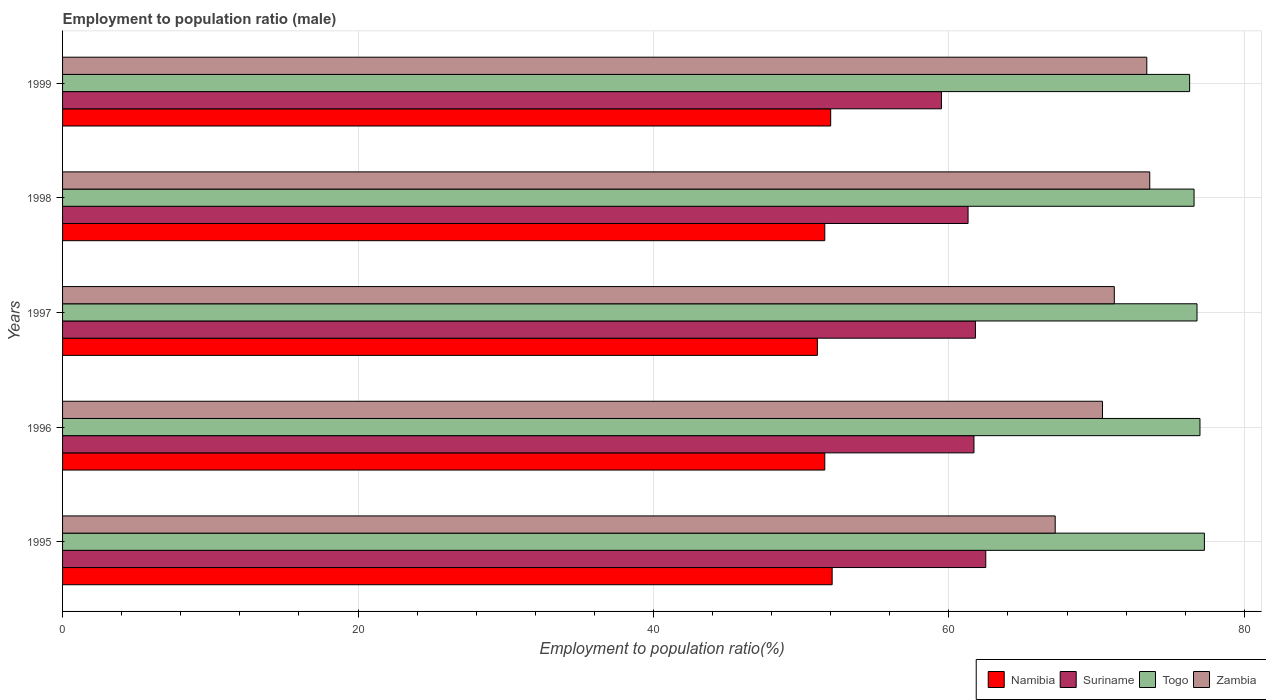How many different coloured bars are there?
Make the answer very short. 4. How many groups of bars are there?
Offer a very short reply. 5. How many bars are there on the 2nd tick from the bottom?
Make the answer very short. 4. What is the label of the 3rd group of bars from the top?
Your answer should be very brief. 1997. In how many cases, is the number of bars for a given year not equal to the number of legend labels?
Your response must be concise. 0. What is the employment to population ratio in Namibia in 1996?
Keep it short and to the point. 51.6. Across all years, what is the maximum employment to population ratio in Zambia?
Provide a succinct answer. 73.6. Across all years, what is the minimum employment to population ratio in Namibia?
Keep it short and to the point. 51.1. In which year was the employment to population ratio in Togo minimum?
Give a very brief answer. 1999. What is the total employment to population ratio in Zambia in the graph?
Your answer should be compact. 355.8. What is the difference between the employment to population ratio in Zambia in 1995 and that in 1999?
Offer a very short reply. -6.2. What is the difference between the employment to population ratio in Suriname in 1995 and the employment to population ratio in Namibia in 1999?
Your answer should be compact. 10.5. What is the average employment to population ratio in Zambia per year?
Offer a terse response. 71.16. In the year 1998, what is the difference between the employment to population ratio in Namibia and employment to population ratio in Suriname?
Your answer should be very brief. -9.7. In how many years, is the employment to population ratio in Togo greater than 32 %?
Your answer should be very brief. 5. What is the ratio of the employment to population ratio in Namibia in 1995 to that in 1998?
Make the answer very short. 1.01. Is the employment to population ratio in Suriname in 1996 less than that in 1998?
Give a very brief answer. No. What is the difference between the highest and the second highest employment to population ratio in Suriname?
Give a very brief answer. 0.7. Is it the case that in every year, the sum of the employment to population ratio in Suriname and employment to population ratio in Togo is greater than the sum of employment to population ratio in Zambia and employment to population ratio in Namibia?
Your answer should be compact. Yes. What does the 3rd bar from the top in 1998 represents?
Provide a short and direct response. Suriname. What does the 2nd bar from the bottom in 1995 represents?
Ensure brevity in your answer.  Suriname. Are all the bars in the graph horizontal?
Keep it short and to the point. Yes. How many years are there in the graph?
Give a very brief answer. 5. Are the values on the major ticks of X-axis written in scientific E-notation?
Ensure brevity in your answer.  No. Does the graph contain any zero values?
Your answer should be compact. No. Where does the legend appear in the graph?
Offer a terse response. Bottom right. How are the legend labels stacked?
Provide a short and direct response. Horizontal. What is the title of the graph?
Your response must be concise. Employment to population ratio (male). What is the label or title of the X-axis?
Give a very brief answer. Employment to population ratio(%). What is the label or title of the Y-axis?
Your answer should be very brief. Years. What is the Employment to population ratio(%) in Namibia in 1995?
Ensure brevity in your answer.  52.1. What is the Employment to population ratio(%) of Suriname in 1995?
Ensure brevity in your answer.  62.5. What is the Employment to population ratio(%) of Togo in 1995?
Ensure brevity in your answer.  77.3. What is the Employment to population ratio(%) of Zambia in 1995?
Provide a succinct answer. 67.2. What is the Employment to population ratio(%) of Namibia in 1996?
Provide a succinct answer. 51.6. What is the Employment to population ratio(%) of Suriname in 1996?
Make the answer very short. 61.7. What is the Employment to population ratio(%) of Togo in 1996?
Keep it short and to the point. 77. What is the Employment to population ratio(%) of Zambia in 1996?
Offer a very short reply. 70.4. What is the Employment to population ratio(%) of Namibia in 1997?
Provide a short and direct response. 51.1. What is the Employment to population ratio(%) of Suriname in 1997?
Make the answer very short. 61.8. What is the Employment to population ratio(%) of Togo in 1997?
Your answer should be very brief. 76.8. What is the Employment to population ratio(%) of Zambia in 1997?
Make the answer very short. 71.2. What is the Employment to population ratio(%) in Namibia in 1998?
Your answer should be compact. 51.6. What is the Employment to population ratio(%) of Suriname in 1998?
Provide a succinct answer. 61.3. What is the Employment to population ratio(%) in Togo in 1998?
Provide a succinct answer. 76.6. What is the Employment to population ratio(%) in Zambia in 1998?
Your response must be concise. 73.6. What is the Employment to population ratio(%) of Namibia in 1999?
Offer a terse response. 52. What is the Employment to population ratio(%) in Suriname in 1999?
Provide a succinct answer. 59.5. What is the Employment to population ratio(%) in Togo in 1999?
Provide a succinct answer. 76.3. What is the Employment to population ratio(%) in Zambia in 1999?
Provide a short and direct response. 73.4. Across all years, what is the maximum Employment to population ratio(%) of Namibia?
Make the answer very short. 52.1. Across all years, what is the maximum Employment to population ratio(%) in Suriname?
Your response must be concise. 62.5. Across all years, what is the maximum Employment to population ratio(%) in Togo?
Offer a terse response. 77.3. Across all years, what is the maximum Employment to population ratio(%) in Zambia?
Give a very brief answer. 73.6. Across all years, what is the minimum Employment to population ratio(%) of Namibia?
Your response must be concise. 51.1. Across all years, what is the minimum Employment to population ratio(%) in Suriname?
Provide a succinct answer. 59.5. Across all years, what is the minimum Employment to population ratio(%) in Togo?
Your answer should be very brief. 76.3. Across all years, what is the minimum Employment to population ratio(%) in Zambia?
Provide a short and direct response. 67.2. What is the total Employment to population ratio(%) in Namibia in the graph?
Offer a very short reply. 258.4. What is the total Employment to population ratio(%) in Suriname in the graph?
Your response must be concise. 306.8. What is the total Employment to population ratio(%) in Togo in the graph?
Your answer should be very brief. 384. What is the total Employment to population ratio(%) in Zambia in the graph?
Make the answer very short. 355.8. What is the difference between the Employment to population ratio(%) of Namibia in 1995 and that in 1996?
Your response must be concise. 0.5. What is the difference between the Employment to population ratio(%) of Zambia in 1995 and that in 1996?
Keep it short and to the point. -3.2. What is the difference between the Employment to population ratio(%) in Togo in 1995 and that in 1997?
Your response must be concise. 0.5. What is the difference between the Employment to population ratio(%) of Namibia in 1995 and that in 1998?
Your response must be concise. 0.5. What is the difference between the Employment to population ratio(%) in Togo in 1995 and that in 1998?
Ensure brevity in your answer.  0.7. What is the difference between the Employment to population ratio(%) in Suriname in 1995 and that in 1999?
Provide a succinct answer. 3. What is the difference between the Employment to population ratio(%) in Togo in 1995 and that in 1999?
Keep it short and to the point. 1. What is the difference between the Employment to population ratio(%) in Namibia in 1996 and that in 1997?
Provide a succinct answer. 0.5. What is the difference between the Employment to population ratio(%) in Suriname in 1996 and that in 1997?
Your answer should be very brief. -0.1. What is the difference between the Employment to population ratio(%) of Togo in 1996 and that in 1997?
Keep it short and to the point. 0.2. What is the difference between the Employment to population ratio(%) in Zambia in 1996 and that in 1997?
Provide a short and direct response. -0.8. What is the difference between the Employment to population ratio(%) in Togo in 1996 and that in 1998?
Give a very brief answer. 0.4. What is the difference between the Employment to population ratio(%) in Zambia in 1996 and that in 1999?
Offer a very short reply. -3. What is the difference between the Employment to population ratio(%) in Zambia in 1997 and that in 1998?
Give a very brief answer. -2.4. What is the difference between the Employment to population ratio(%) of Namibia in 1997 and that in 1999?
Offer a very short reply. -0.9. What is the difference between the Employment to population ratio(%) in Suriname in 1997 and that in 1999?
Keep it short and to the point. 2.3. What is the difference between the Employment to population ratio(%) of Zambia in 1997 and that in 1999?
Provide a succinct answer. -2.2. What is the difference between the Employment to population ratio(%) in Togo in 1998 and that in 1999?
Provide a short and direct response. 0.3. What is the difference between the Employment to population ratio(%) of Zambia in 1998 and that in 1999?
Ensure brevity in your answer.  0.2. What is the difference between the Employment to population ratio(%) of Namibia in 1995 and the Employment to population ratio(%) of Togo in 1996?
Provide a short and direct response. -24.9. What is the difference between the Employment to population ratio(%) of Namibia in 1995 and the Employment to population ratio(%) of Zambia in 1996?
Give a very brief answer. -18.3. What is the difference between the Employment to population ratio(%) of Suriname in 1995 and the Employment to population ratio(%) of Togo in 1996?
Ensure brevity in your answer.  -14.5. What is the difference between the Employment to population ratio(%) in Namibia in 1995 and the Employment to population ratio(%) in Suriname in 1997?
Your response must be concise. -9.7. What is the difference between the Employment to population ratio(%) in Namibia in 1995 and the Employment to population ratio(%) in Togo in 1997?
Keep it short and to the point. -24.7. What is the difference between the Employment to population ratio(%) in Namibia in 1995 and the Employment to population ratio(%) in Zambia in 1997?
Your answer should be very brief. -19.1. What is the difference between the Employment to population ratio(%) of Suriname in 1995 and the Employment to population ratio(%) of Togo in 1997?
Give a very brief answer. -14.3. What is the difference between the Employment to population ratio(%) of Togo in 1995 and the Employment to population ratio(%) of Zambia in 1997?
Ensure brevity in your answer.  6.1. What is the difference between the Employment to population ratio(%) in Namibia in 1995 and the Employment to population ratio(%) in Togo in 1998?
Provide a short and direct response. -24.5. What is the difference between the Employment to population ratio(%) in Namibia in 1995 and the Employment to population ratio(%) in Zambia in 1998?
Give a very brief answer. -21.5. What is the difference between the Employment to population ratio(%) of Suriname in 1995 and the Employment to population ratio(%) of Togo in 1998?
Provide a short and direct response. -14.1. What is the difference between the Employment to population ratio(%) in Suriname in 1995 and the Employment to population ratio(%) in Zambia in 1998?
Keep it short and to the point. -11.1. What is the difference between the Employment to population ratio(%) of Togo in 1995 and the Employment to population ratio(%) of Zambia in 1998?
Offer a very short reply. 3.7. What is the difference between the Employment to population ratio(%) of Namibia in 1995 and the Employment to population ratio(%) of Suriname in 1999?
Offer a very short reply. -7.4. What is the difference between the Employment to population ratio(%) of Namibia in 1995 and the Employment to population ratio(%) of Togo in 1999?
Offer a terse response. -24.2. What is the difference between the Employment to population ratio(%) of Namibia in 1995 and the Employment to population ratio(%) of Zambia in 1999?
Ensure brevity in your answer.  -21.3. What is the difference between the Employment to population ratio(%) in Suriname in 1995 and the Employment to population ratio(%) in Zambia in 1999?
Provide a succinct answer. -10.9. What is the difference between the Employment to population ratio(%) of Togo in 1995 and the Employment to population ratio(%) of Zambia in 1999?
Ensure brevity in your answer.  3.9. What is the difference between the Employment to population ratio(%) of Namibia in 1996 and the Employment to population ratio(%) of Suriname in 1997?
Your answer should be compact. -10.2. What is the difference between the Employment to population ratio(%) of Namibia in 1996 and the Employment to population ratio(%) of Togo in 1997?
Offer a terse response. -25.2. What is the difference between the Employment to population ratio(%) in Namibia in 1996 and the Employment to population ratio(%) in Zambia in 1997?
Your response must be concise. -19.6. What is the difference between the Employment to population ratio(%) in Suriname in 1996 and the Employment to population ratio(%) in Togo in 1997?
Provide a succinct answer. -15.1. What is the difference between the Employment to population ratio(%) in Suriname in 1996 and the Employment to population ratio(%) in Zambia in 1997?
Make the answer very short. -9.5. What is the difference between the Employment to population ratio(%) in Namibia in 1996 and the Employment to population ratio(%) in Togo in 1998?
Provide a short and direct response. -25. What is the difference between the Employment to population ratio(%) of Namibia in 1996 and the Employment to population ratio(%) of Zambia in 1998?
Keep it short and to the point. -22. What is the difference between the Employment to population ratio(%) of Suriname in 1996 and the Employment to population ratio(%) of Togo in 1998?
Offer a terse response. -14.9. What is the difference between the Employment to population ratio(%) of Namibia in 1996 and the Employment to population ratio(%) of Togo in 1999?
Offer a terse response. -24.7. What is the difference between the Employment to population ratio(%) of Namibia in 1996 and the Employment to population ratio(%) of Zambia in 1999?
Offer a very short reply. -21.8. What is the difference between the Employment to population ratio(%) in Suriname in 1996 and the Employment to population ratio(%) in Togo in 1999?
Your response must be concise. -14.6. What is the difference between the Employment to population ratio(%) in Suriname in 1996 and the Employment to population ratio(%) in Zambia in 1999?
Provide a short and direct response. -11.7. What is the difference between the Employment to population ratio(%) in Togo in 1996 and the Employment to population ratio(%) in Zambia in 1999?
Ensure brevity in your answer.  3.6. What is the difference between the Employment to population ratio(%) in Namibia in 1997 and the Employment to population ratio(%) in Suriname in 1998?
Keep it short and to the point. -10.2. What is the difference between the Employment to population ratio(%) in Namibia in 1997 and the Employment to population ratio(%) in Togo in 1998?
Your response must be concise. -25.5. What is the difference between the Employment to population ratio(%) in Namibia in 1997 and the Employment to population ratio(%) in Zambia in 1998?
Offer a terse response. -22.5. What is the difference between the Employment to population ratio(%) in Suriname in 1997 and the Employment to population ratio(%) in Togo in 1998?
Offer a terse response. -14.8. What is the difference between the Employment to population ratio(%) of Suriname in 1997 and the Employment to population ratio(%) of Zambia in 1998?
Provide a short and direct response. -11.8. What is the difference between the Employment to population ratio(%) of Togo in 1997 and the Employment to population ratio(%) of Zambia in 1998?
Make the answer very short. 3.2. What is the difference between the Employment to population ratio(%) of Namibia in 1997 and the Employment to population ratio(%) of Togo in 1999?
Offer a terse response. -25.2. What is the difference between the Employment to population ratio(%) in Namibia in 1997 and the Employment to population ratio(%) in Zambia in 1999?
Provide a short and direct response. -22.3. What is the difference between the Employment to population ratio(%) in Suriname in 1997 and the Employment to population ratio(%) in Togo in 1999?
Your answer should be very brief. -14.5. What is the difference between the Employment to population ratio(%) in Togo in 1997 and the Employment to population ratio(%) in Zambia in 1999?
Provide a short and direct response. 3.4. What is the difference between the Employment to population ratio(%) of Namibia in 1998 and the Employment to population ratio(%) of Togo in 1999?
Offer a terse response. -24.7. What is the difference between the Employment to population ratio(%) in Namibia in 1998 and the Employment to population ratio(%) in Zambia in 1999?
Your answer should be compact. -21.8. What is the difference between the Employment to population ratio(%) of Suriname in 1998 and the Employment to population ratio(%) of Togo in 1999?
Give a very brief answer. -15. What is the difference between the Employment to population ratio(%) in Togo in 1998 and the Employment to population ratio(%) in Zambia in 1999?
Offer a very short reply. 3.2. What is the average Employment to population ratio(%) in Namibia per year?
Provide a succinct answer. 51.68. What is the average Employment to population ratio(%) in Suriname per year?
Your answer should be compact. 61.36. What is the average Employment to population ratio(%) in Togo per year?
Your answer should be compact. 76.8. What is the average Employment to population ratio(%) in Zambia per year?
Offer a terse response. 71.16. In the year 1995, what is the difference between the Employment to population ratio(%) of Namibia and Employment to population ratio(%) of Suriname?
Your answer should be compact. -10.4. In the year 1995, what is the difference between the Employment to population ratio(%) of Namibia and Employment to population ratio(%) of Togo?
Provide a succinct answer. -25.2. In the year 1995, what is the difference between the Employment to population ratio(%) in Namibia and Employment to population ratio(%) in Zambia?
Give a very brief answer. -15.1. In the year 1995, what is the difference between the Employment to population ratio(%) of Suriname and Employment to population ratio(%) of Togo?
Provide a succinct answer. -14.8. In the year 1995, what is the difference between the Employment to population ratio(%) in Suriname and Employment to population ratio(%) in Zambia?
Ensure brevity in your answer.  -4.7. In the year 1995, what is the difference between the Employment to population ratio(%) of Togo and Employment to population ratio(%) of Zambia?
Your response must be concise. 10.1. In the year 1996, what is the difference between the Employment to population ratio(%) in Namibia and Employment to population ratio(%) in Suriname?
Provide a short and direct response. -10.1. In the year 1996, what is the difference between the Employment to population ratio(%) of Namibia and Employment to population ratio(%) of Togo?
Provide a succinct answer. -25.4. In the year 1996, what is the difference between the Employment to population ratio(%) in Namibia and Employment to population ratio(%) in Zambia?
Offer a terse response. -18.8. In the year 1996, what is the difference between the Employment to population ratio(%) of Suriname and Employment to population ratio(%) of Togo?
Ensure brevity in your answer.  -15.3. In the year 1996, what is the difference between the Employment to population ratio(%) of Togo and Employment to population ratio(%) of Zambia?
Your response must be concise. 6.6. In the year 1997, what is the difference between the Employment to population ratio(%) in Namibia and Employment to population ratio(%) in Suriname?
Your response must be concise. -10.7. In the year 1997, what is the difference between the Employment to population ratio(%) of Namibia and Employment to population ratio(%) of Togo?
Provide a succinct answer. -25.7. In the year 1997, what is the difference between the Employment to population ratio(%) of Namibia and Employment to population ratio(%) of Zambia?
Provide a short and direct response. -20.1. In the year 1997, what is the difference between the Employment to population ratio(%) in Suriname and Employment to population ratio(%) in Togo?
Make the answer very short. -15. In the year 1997, what is the difference between the Employment to population ratio(%) in Suriname and Employment to population ratio(%) in Zambia?
Offer a terse response. -9.4. In the year 1997, what is the difference between the Employment to population ratio(%) in Togo and Employment to population ratio(%) in Zambia?
Ensure brevity in your answer.  5.6. In the year 1998, what is the difference between the Employment to population ratio(%) in Namibia and Employment to population ratio(%) in Suriname?
Give a very brief answer. -9.7. In the year 1998, what is the difference between the Employment to population ratio(%) in Namibia and Employment to population ratio(%) in Togo?
Your response must be concise. -25. In the year 1998, what is the difference between the Employment to population ratio(%) of Namibia and Employment to population ratio(%) of Zambia?
Keep it short and to the point. -22. In the year 1998, what is the difference between the Employment to population ratio(%) of Suriname and Employment to population ratio(%) of Togo?
Give a very brief answer. -15.3. In the year 1998, what is the difference between the Employment to population ratio(%) in Togo and Employment to population ratio(%) in Zambia?
Your answer should be very brief. 3. In the year 1999, what is the difference between the Employment to population ratio(%) of Namibia and Employment to population ratio(%) of Togo?
Offer a very short reply. -24.3. In the year 1999, what is the difference between the Employment to population ratio(%) in Namibia and Employment to population ratio(%) in Zambia?
Your answer should be compact. -21.4. In the year 1999, what is the difference between the Employment to population ratio(%) in Suriname and Employment to population ratio(%) in Togo?
Your answer should be very brief. -16.8. In the year 1999, what is the difference between the Employment to population ratio(%) of Togo and Employment to population ratio(%) of Zambia?
Ensure brevity in your answer.  2.9. What is the ratio of the Employment to population ratio(%) of Namibia in 1995 to that in 1996?
Your answer should be compact. 1.01. What is the ratio of the Employment to population ratio(%) of Suriname in 1995 to that in 1996?
Make the answer very short. 1.01. What is the ratio of the Employment to population ratio(%) in Togo in 1995 to that in 1996?
Your response must be concise. 1. What is the ratio of the Employment to population ratio(%) in Zambia in 1995 to that in 1996?
Your response must be concise. 0.95. What is the ratio of the Employment to population ratio(%) of Namibia in 1995 to that in 1997?
Make the answer very short. 1.02. What is the ratio of the Employment to population ratio(%) in Suriname in 1995 to that in 1997?
Keep it short and to the point. 1.01. What is the ratio of the Employment to population ratio(%) of Togo in 1995 to that in 1997?
Your answer should be very brief. 1.01. What is the ratio of the Employment to population ratio(%) in Zambia in 1995 to that in 1997?
Provide a short and direct response. 0.94. What is the ratio of the Employment to population ratio(%) of Namibia in 1995 to that in 1998?
Ensure brevity in your answer.  1.01. What is the ratio of the Employment to population ratio(%) of Suriname in 1995 to that in 1998?
Provide a short and direct response. 1.02. What is the ratio of the Employment to population ratio(%) in Togo in 1995 to that in 1998?
Provide a short and direct response. 1.01. What is the ratio of the Employment to population ratio(%) in Suriname in 1995 to that in 1999?
Provide a short and direct response. 1.05. What is the ratio of the Employment to population ratio(%) in Togo in 1995 to that in 1999?
Your response must be concise. 1.01. What is the ratio of the Employment to population ratio(%) of Zambia in 1995 to that in 1999?
Keep it short and to the point. 0.92. What is the ratio of the Employment to population ratio(%) in Namibia in 1996 to that in 1997?
Your answer should be very brief. 1.01. What is the ratio of the Employment to population ratio(%) of Zambia in 1996 to that in 1997?
Offer a terse response. 0.99. What is the ratio of the Employment to population ratio(%) of Namibia in 1996 to that in 1998?
Ensure brevity in your answer.  1. What is the ratio of the Employment to population ratio(%) of Zambia in 1996 to that in 1998?
Make the answer very short. 0.96. What is the ratio of the Employment to population ratio(%) in Togo in 1996 to that in 1999?
Give a very brief answer. 1.01. What is the ratio of the Employment to population ratio(%) of Zambia in 1996 to that in 1999?
Ensure brevity in your answer.  0.96. What is the ratio of the Employment to population ratio(%) of Namibia in 1997 to that in 1998?
Give a very brief answer. 0.99. What is the ratio of the Employment to population ratio(%) in Suriname in 1997 to that in 1998?
Keep it short and to the point. 1.01. What is the ratio of the Employment to population ratio(%) of Zambia in 1997 to that in 1998?
Keep it short and to the point. 0.97. What is the ratio of the Employment to population ratio(%) of Namibia in 1997 to that in 1999?
Provide a succinct answer. 0.98. What is the ratio of the Employment to population ratio(%) in Suriname in 1997 to that in 1999?
Ensure brevity in your answer.  1.04. What is the ratio of the Employment to population ratio(%) in Togo in 1997 to that in 1999?
Offer a terse response. 1.01. What is the ratio of the Employment to population ratio(%) in Zambia in 1997 to that in 1999?
Ensure brevity in your answer.  0.97. What is the ratio of the Employment to population ratio(%) of Namibia in 1998 to that in 1999?
Ensure brevity in your answer.  0.99. What is the ratio of the Employment to population ratio(%) in Suriname in 1998 to that in 1999?
Provide a short and direct response. 1.03. What is the ratio of the Employment to population ratio(%) in Togo in 1998 to that in 1999?
Offer a terse response. 1. What is the difference between the highest and the second highest Employment to population ratio(%) in Namibia?
Your response must be concise. 0.1. What is the difference between the highest and the second highest Employment to population ratio(%) in Suriname?
Offer a terse response. 0.7. What is the difference between the highest and the second highest Employment to population ratio(%) in Togo?
Your response must be concise. 0.3. What is the difference between the highest and the lowest Employment to population ratio(%) in Namibia?
Keep it short and to the point. 1. What is the difference between the highest and the lowest Employment to population ratio(%) in Suriname?
Offer a terse response. 3. What is the difference between the highest and the lowest Employment to population ratio(%) of Zambia?
Provide a short and direct response. 6.4. 